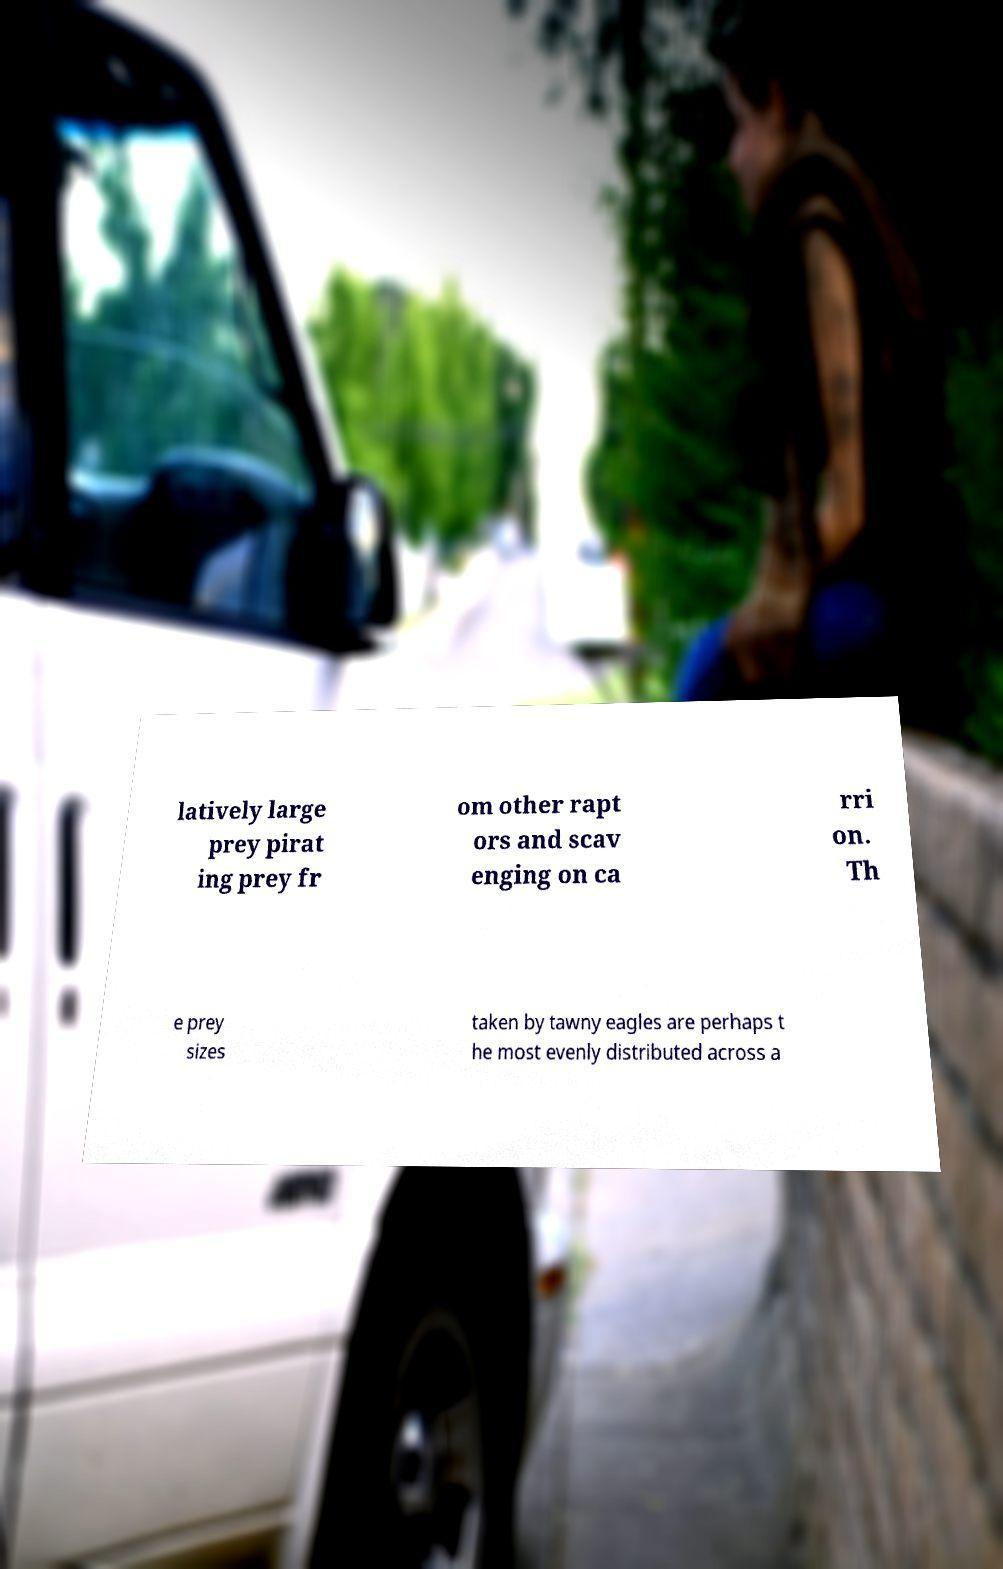Please read and relay the text visible in this image. What does it say? latively large prey pirat ing prey fr om other rapt ors and scav enging on ca rri on. Th e prey sizes taken by tawny eagles are perhaps t he most evenly distributed across a 